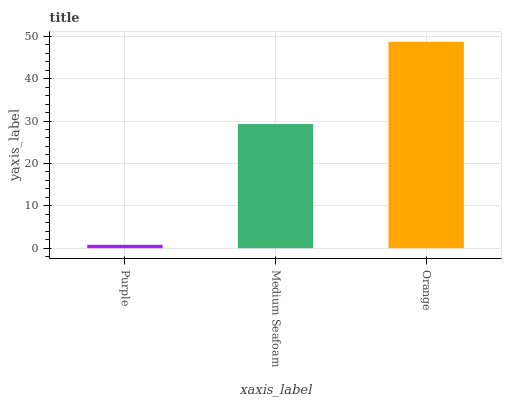Is Purple the minimum?
Answer yes or no. Yes. Is Orange the maximum?
Answer yes or no. Yes. Is Medium Seafoam the minimum?
Answer yes or no. No. Is Medium Seafoam the maximum?
Answer yes or no. No. Is Medium Seafoam greater than Purple?
Answer yes or no. Yes. Is Purple less than Medium Seafoam?
Answer yes or no. Yes. Is Purple greater than Medium Seafoam?
Answer yes or no. No. Is Medium Seafoam less than Purple?
Answer yes or no. No. Is Medium Seafoam the high median?
Answer yes or no. Yes. Is Medium Seafoam the low median?
Answer yes or no. Yes. Is Purple the high median?
Answer yes or no. No. Is Orange the low median?
Answer yes or no. No. 